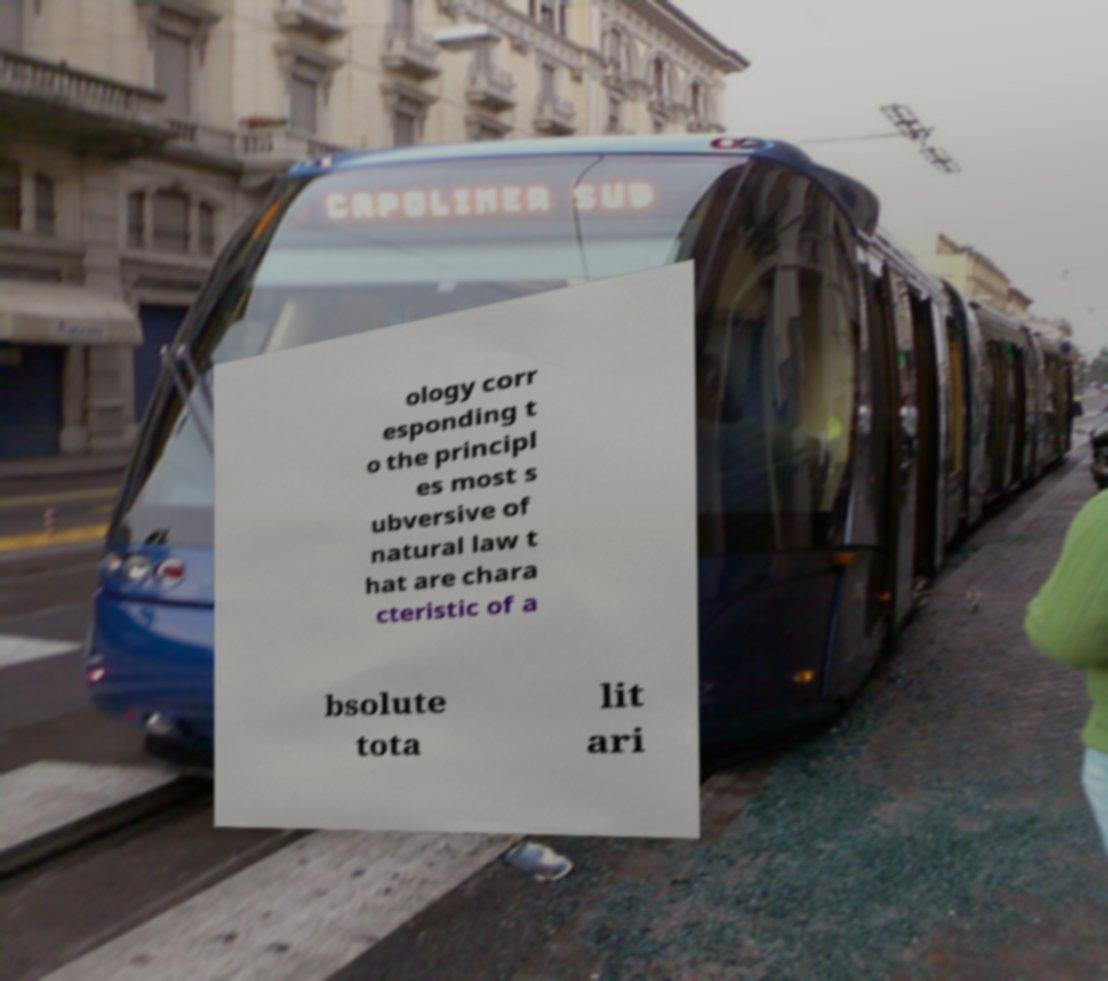There's text embedded in this image that I need extracted. Can you transcribe it verbatim? ology corr esponding t o the principl es most s ubversive of natural law t hat are chara cteristic of a bsolute tota lit ari 